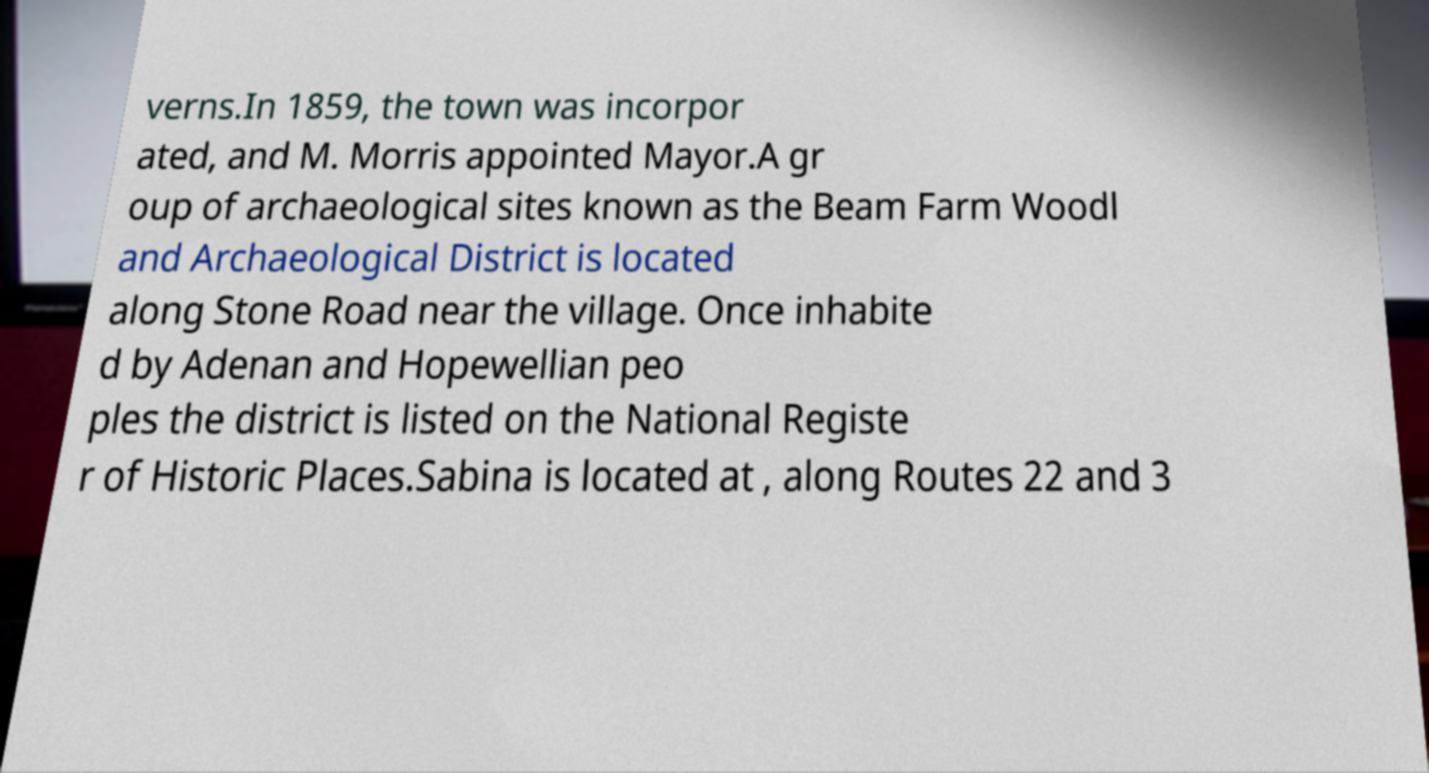Please identify and transcribe the text found in this image. verns.In 1859, the town was incorpor ated, and M. Morris appointed Mayor.A gr oup of archaeological sites known as the Beam Farm Woodl and Archaeological District is located along Stone Road near the village. Once inhabite d by Adenan and Hopewellian peo ples the district is listed on the National Registe r of Historic Places.Sabina is located at , along Routes 22 and 3 